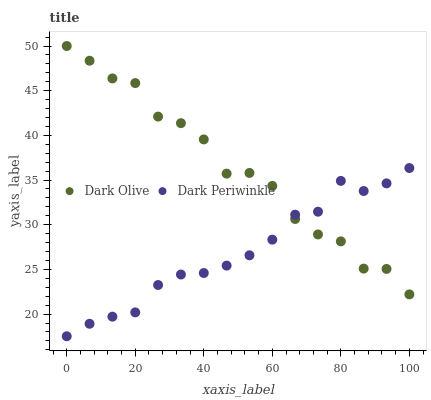Does Dark Periwinkle have the minimum area under the curve?
Answer yes or no. Yes. Does Dark Olive have the maximum area under the curve?
Answer yes or no. Yes. Does Dark Periwinkle have the maximum area under the curve?
Answer yes or no. No. Is Dark Periwinkle the smoothest?
Answer yes or no. Yes. Is Dark Olive the roughest?
Answer yes or no. Yes. Is Dark Periwinkle the roughest?
Answer yes or no. No. Does Dark Periwinkle have the lowest value?
Answer yes or no. Yes. Does Dark Olive have the highest value?
Answer yes or no. Yes. Does Dark Periwinkle have the highest value?
Answer yes or no. No. Does Dark Olive intersect Dark Periwinkle?
Answer yes or no. Yes. Is Dark Olive less than Dark Periwinkle?
Answer yes or no. No. Is Dark Olive greater than Dark Periwinkle?
Answer yes or no. No. 